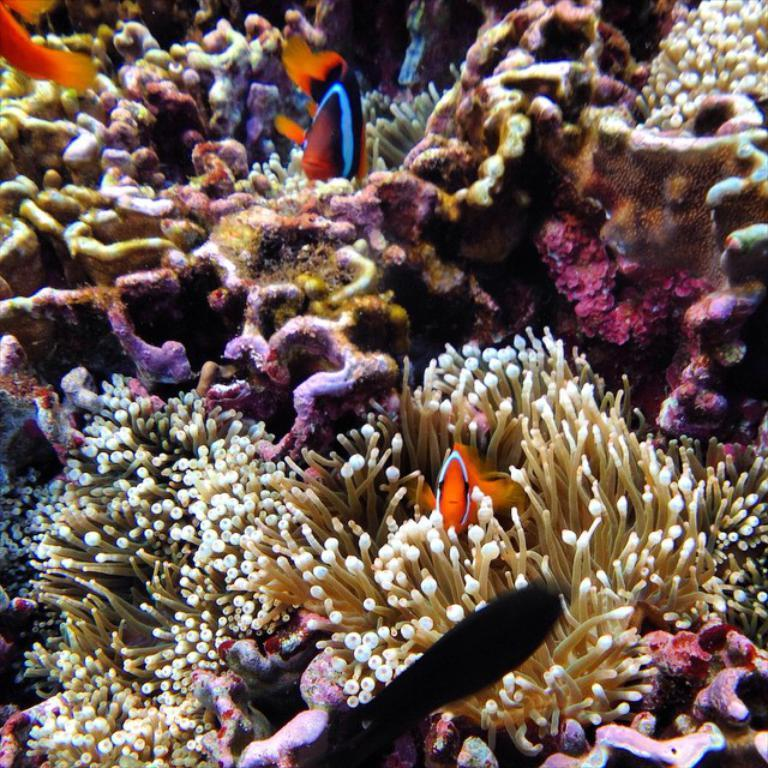What type of environment is depicted in the image? The image shows an underwater environment. What can be seen in the water besides the plants? There are fishes in the image. Can you describe the underwater plants in the image? The underwater plants in the image are visible and appear to be part of the aquatic ecosystem. What decision did the fish make in the image? There is no indication in the image that the fish made any decisions. What substance is the fish holding in the image? There is no substance visible in the image that the fish might be holding. 